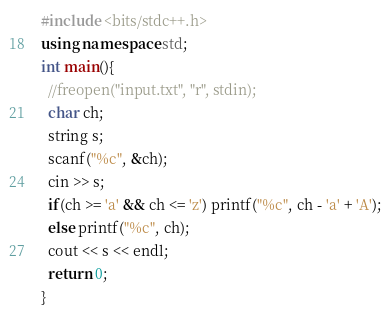<code> <loc_0><loc_0><loc_500><loc_500><_C++_>#include <bits/stdc++.h>
using namespace std;
int main(){
  //freopen("input.txt", "r", stdin);
  char ch;
  string s;
  scanf("%c", &ch);
  cin >> s;
  if(ch >= 'a' && ch <= 'z') printf("%c", ch - 'a' + 'A');
  else printf("%c", ch);
  cout << s << endl;
  return 0;
}
</code> 